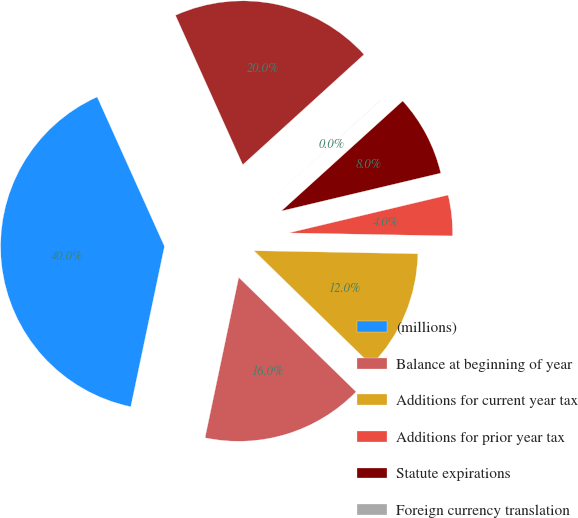Convert chart. <chart><loc_0><loc_0><loc_500><loc_500><pie_chart><fcel>(millions)<fcel>Balance at beginning of year<fcel>Additions for current year tax<fcel>Additions for prior year tax<fcel>Statute expirations<fcel>Foreign currency translation<fcel>Balance at November 30<nl><fcel>39.97%<fcel>16.0%<fcel>12.0%<fcel>4.01%<fcel>8.01%<fcel>0.02%<fcel>19.99%<nl></chart> 